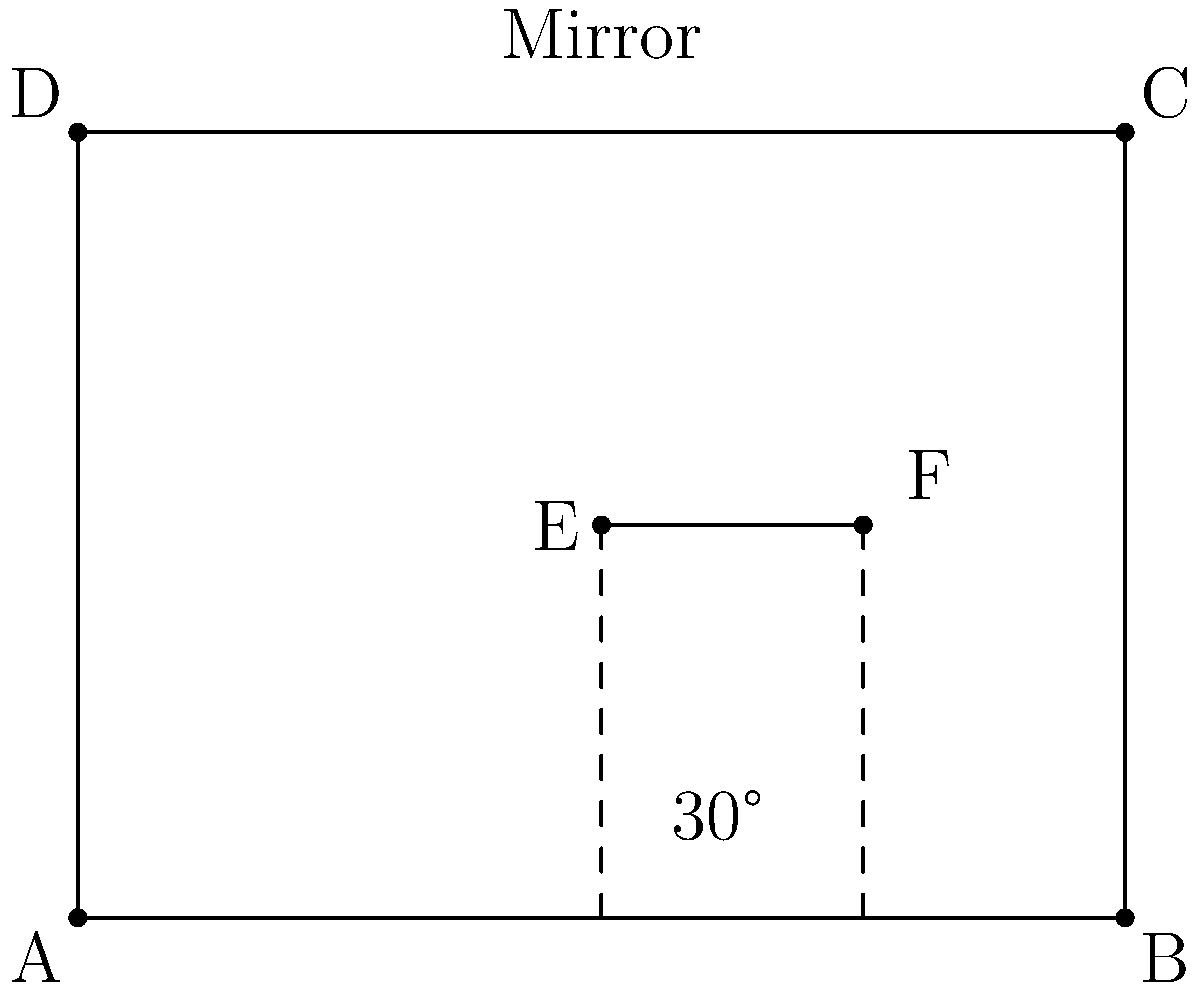In a royal chamber, a hidden camera is placed at point E, 1.5 meters above the floor and 2 meters from the left wall. A large mirror covers the entire right wall (BC). If the camera's line of sight makes a 30° angle with the floor, at what height will the reflected ray hit the right wall? Let's approach this step-by-step:

1) First, we need to understand the law of reflection: the angle of incidence equals the angle of reflection.

2) In this case, the angle of incidence (and reflection) is 30°.

3) We can treat this as a right triangle problem. Let's call the point where the ray hits the mirror F.

4) We know that:
   - The distance from E to the right wall is 2 meters (4m - 2m)
   - The height of E from the floor is 1.5 meters

5) In the right triangle EFG (where G is the point directly below F on the floor):
   $\tan(30°) = \frac{\text{opposite}}{\text{adjacent}} = \frac{\text{height difference}}{\text{distance}}$

6) We can calculate this height difference:
   $\text{height difference} = 2 \cdot \tan(30°) = 2 \cdot \frac{1}{\sqrt{3}} \approx 1.15$ meters

7) This height difference is added to the initial height of the camera:
   $1.5 + 1.15 = 2.65$ meters

Therefore, the reflected ray will hit the right wall at a height of approximately 2.65 meters.
Answer: 2.65 meters 